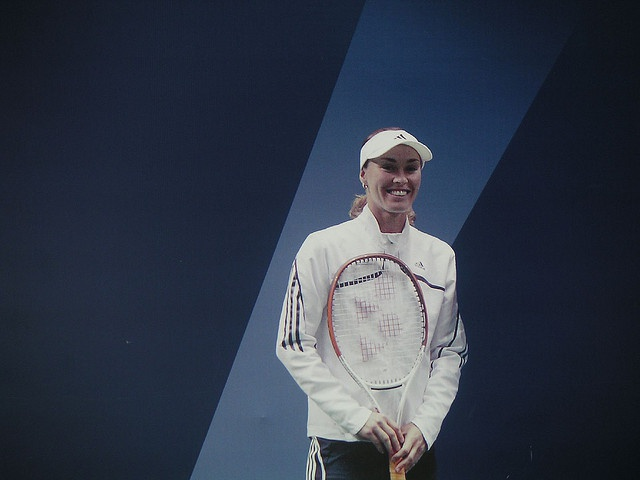Describe the objects in this image and their specific colors. I can see people in black, darkgray, lightgray, and gray tones and tennis racket in black, darkgray, and lightgray tones in this image. 